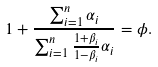<formula> <loc_0><loc_0><loc_500><loc_500>1 + \frac { \sum _ { i = 1 } ^ { n } \alpha _ { i } } { \sum _ { i = 1 } ^ { n } \frac { 1 + \beta _ { i } } { 1 - \beta _ { i } } \alpha _ { i } } = \phi .</formula> 